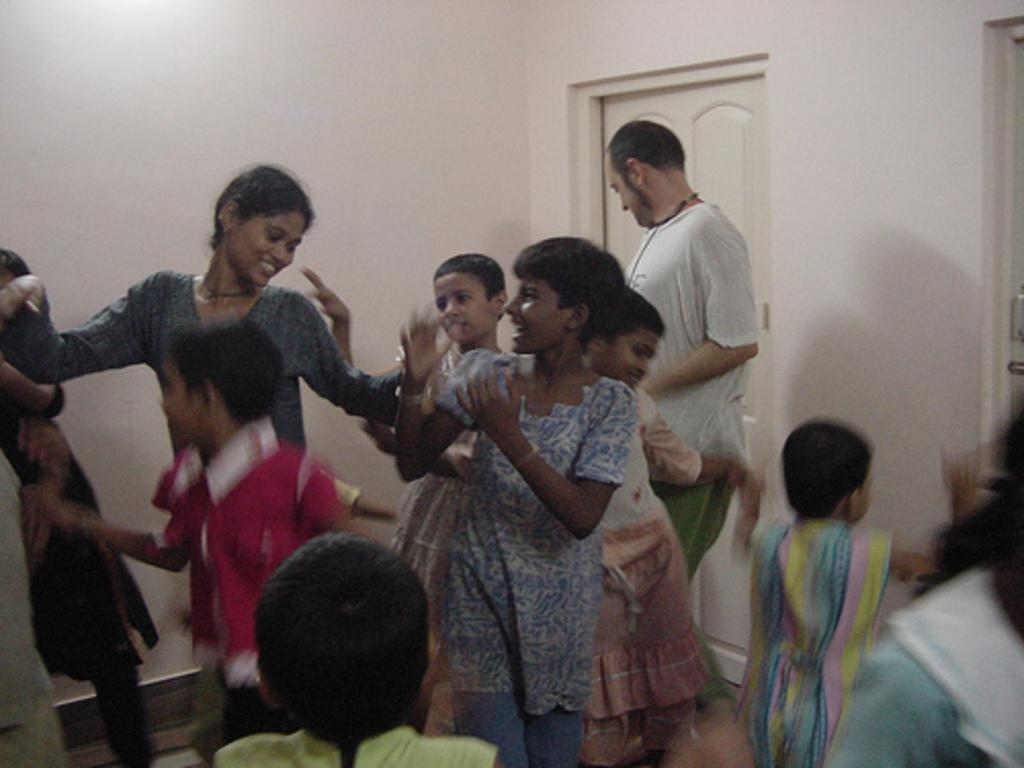What are the people in the image doing? The people in the image are dancing. What color is the door visible in the image? The door visible in the image is white. What else is white in the image besides the door? There is also a white wall visible in the image. What type of milk is being used as bait in the image? There is no milk or bait present in the image; it features people dancing with a white door and wall. 